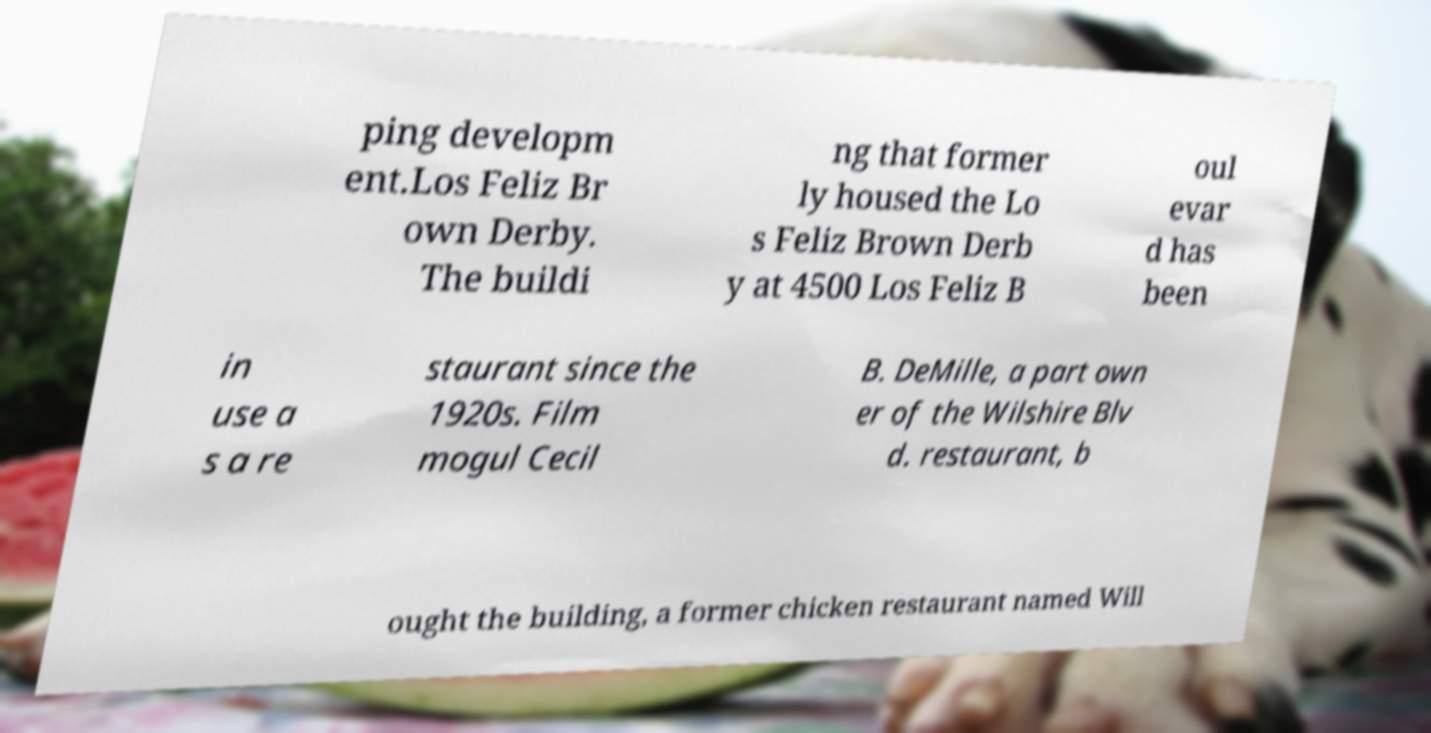Can you read and provide the text displayed in the image?This photo seems to have some interesting text. Can you extract and type it out for me? ping developm ent.Los Feliz Br own Derby. The buildi ng that former ly housed the Lo s Feliz Brown Derb y at 4500 Los Feliz B oul evar d has been in use a s a re staurant since the 1920s. Film mogul Cecil B. DeMille, a part own er of the Wilshire Blv d. restaurant, b ought the building, a former chicken restaurant named Will 